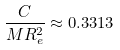Convert formula to latex. <formula><loc_0><loc_0><loc_500><loc_500>\frac { C } { M R _ { e } ^ { 2 } } \approx 0 . 3 3 1 3</formula> 